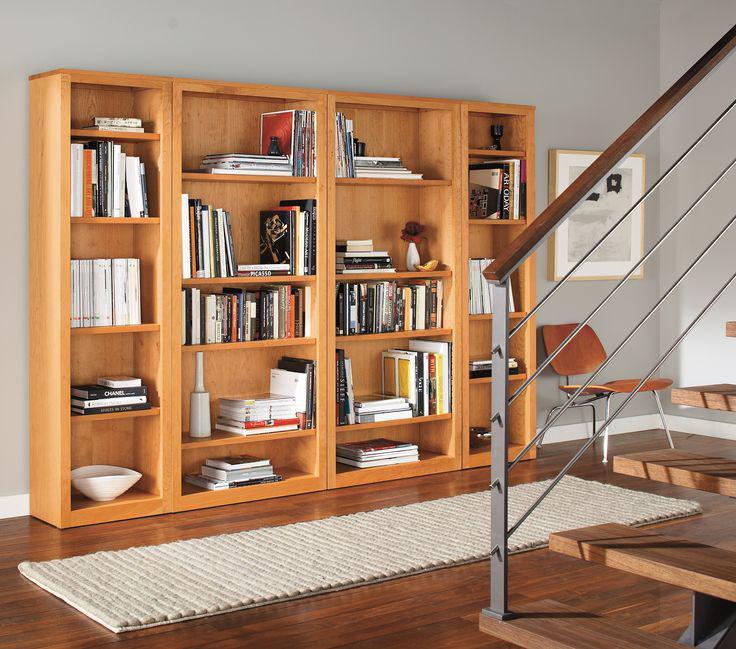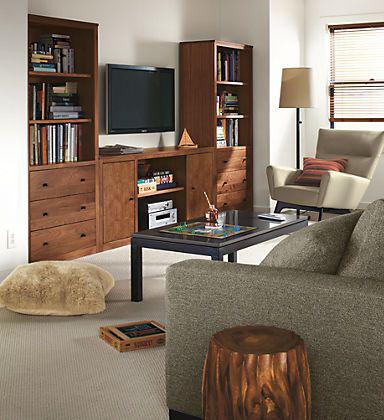The first image is the image on the left, the second image is the image on the right. Considering the images on both sides, is "There is a television set in between two bookcases." valid? Answer yes or no. Yes. The first image is the image on the left, the second image is the image on the right. Assess this claim about the two images: "A TV is sitting on a stand between two bookshelves.". Correct or not? Answer yes or no. Yes. 